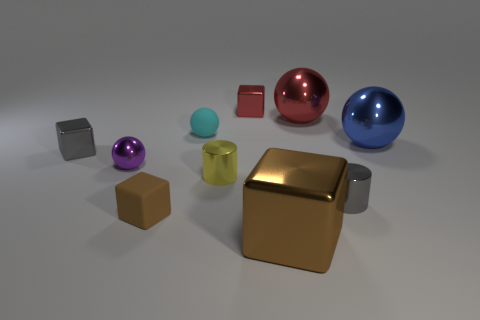Subtract all tiny cyan matte balls. How many balls are left? 3 Subtract all yellow cylinders. How many cylinders are left? 1 Subtract 3 blocks. How many blocks are left? 1 Add 3 gray shiny cylinders. How many gray shiny cylinders are left? 4 Add 6 large red shiny things. How many large red shiny things exist? 7 Subtract 1 purple balls. How many objects are left? 9 Subtract all blocks. How many objects are left? 6 Subtract all green cubes. Subtract all gray cylinders. How many cubes are left? 4 Subtract all yellow blocks. How many brown cylinders are left? 0 Subtract all tiny brown things. Subtract all matte spheres. How many objects are left? 8 